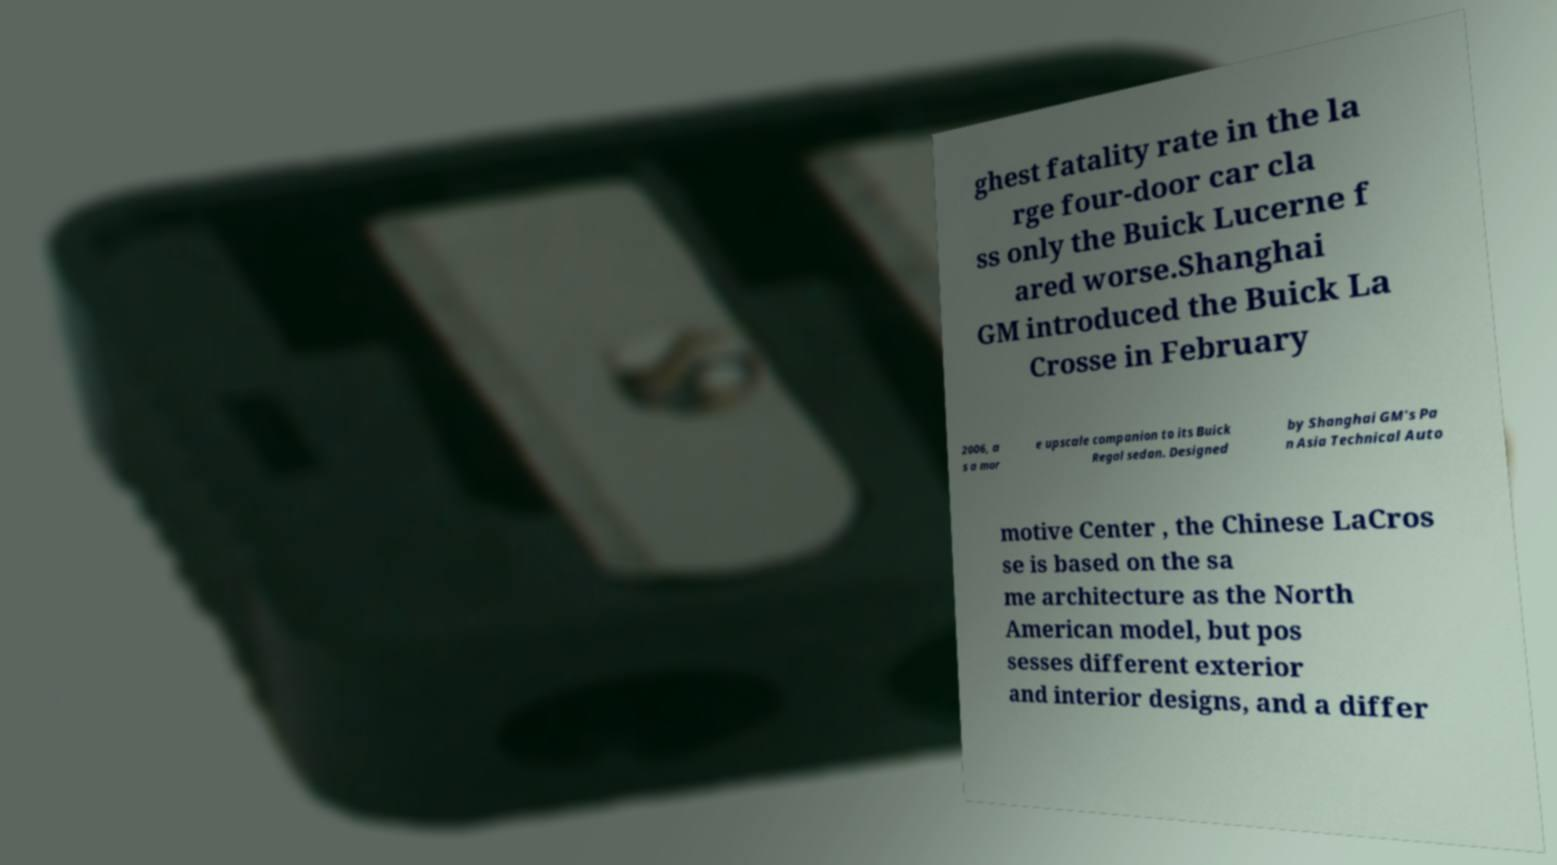Can you read and provide the text displayed in the image?This photo seems to have some interesting text. Can you extract and type it out for me? ghest fatality rate in the la rge four-door car cla ss only the Buick Lucerne f ared worse.Shanghai GM introduced the Buick La Crosse in February 2006, a s a mor e upscale companion to its Buick Regal sedan. Designed by Shanghai GM's Pa n Asia Technical Auto motive Center , the Chinese LaCros se is based on the sa me architecture as the North American model, but pos sesses different exterior and interior designs, and a differ 